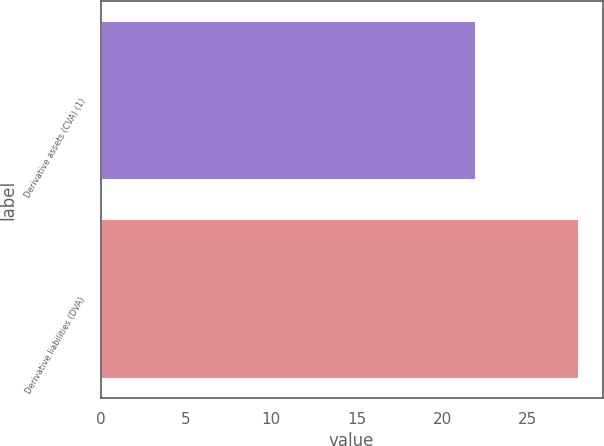Convert chart to OTSL. <chart><loc_0><loc_0><loc_500><loc_500><bar_chart><fcel>Derivative assets (CVA) (1)<fcel>Derivative liabilities (DVA)<nl><fcel>22<fcel>28<nl></chart> 